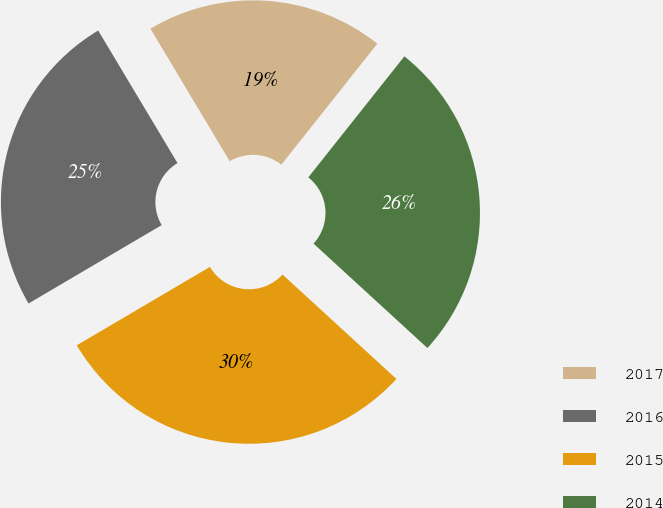<chart> <loc_0><loc_0><loc_500><loc_500><pie_chart><fcel>2017<fcel>2016<fcel>2015<fcel>2014<nl><fcel>19.26%<fcel>24.89%<fcel>29.72%<fcel>26.13%<nl></chart> 